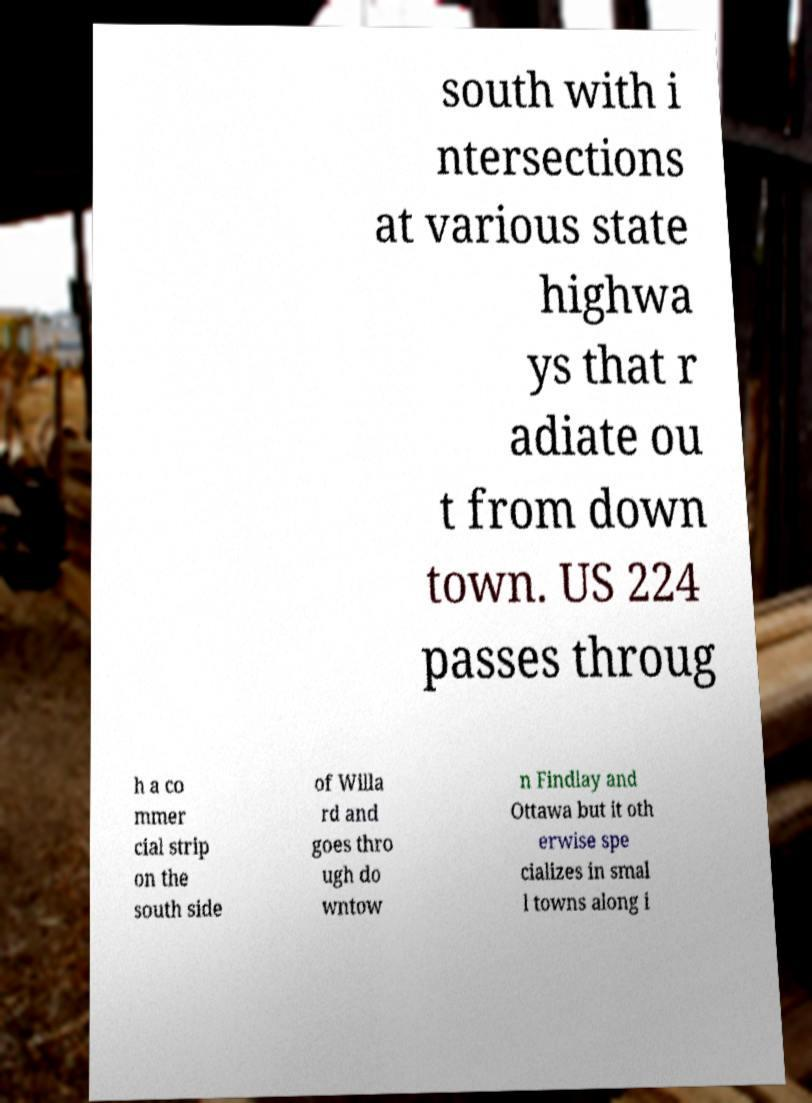There's text embedded in this image that I need extracted. Can you transcribe it verbatim? south with i ntersections at various state highwa ys that r adiate ou t from down town. US 224 passes throug h a co mmer cial strip on the south side of Willa rd and goes thro ugh do wntow n Findlay and Ottawa but it oth erwise spe cializes in smal l towns along i 